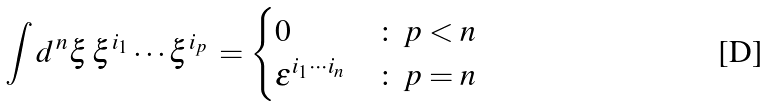<formula> <loc_0><loc_0><loc_500><loc_500>\int d ^ { \, n } \xi \, \xi ^ { i _ { 1 } } \cdots \xi ^ { i _ { p } } \, = \begin{cases} 0 & \colon \, p < n \\ \varepsilon ^ { i _ { 1 } \cdots i _ { n } } & \colon \, p = n \end{cases}</formula> 